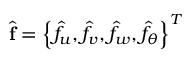<formula> <loc_0><loc_0><loc_500><loc_500>\widehat { f } = \left \{ \widehat { f } _ { u } , \widehat { f } _ { v } , \widehat { f } _ { w } , \widehat { f } _ { \theta } \right \} ^ { T }</formula> 